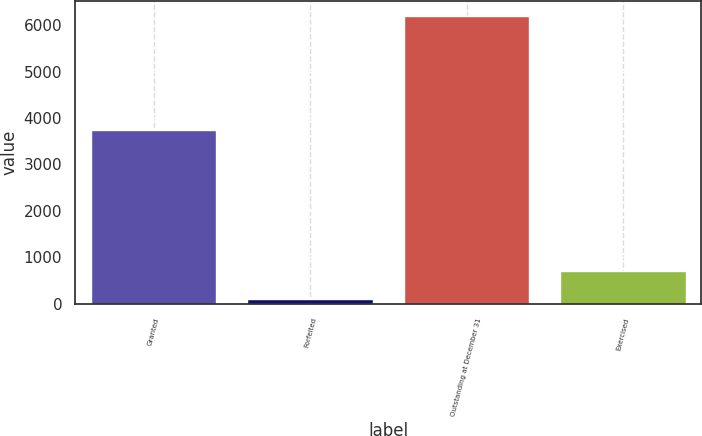<chart> <loc_0><loc_0><loc_500><loc_500><bar_chart><fcel>Granted<fcel>Forfeited<fcel>Outstanding at December 31<fcel>Exercised<nl><fcel>3749.3<fcel>106<fcel>6199<fcel>715.3<nl></chart> 